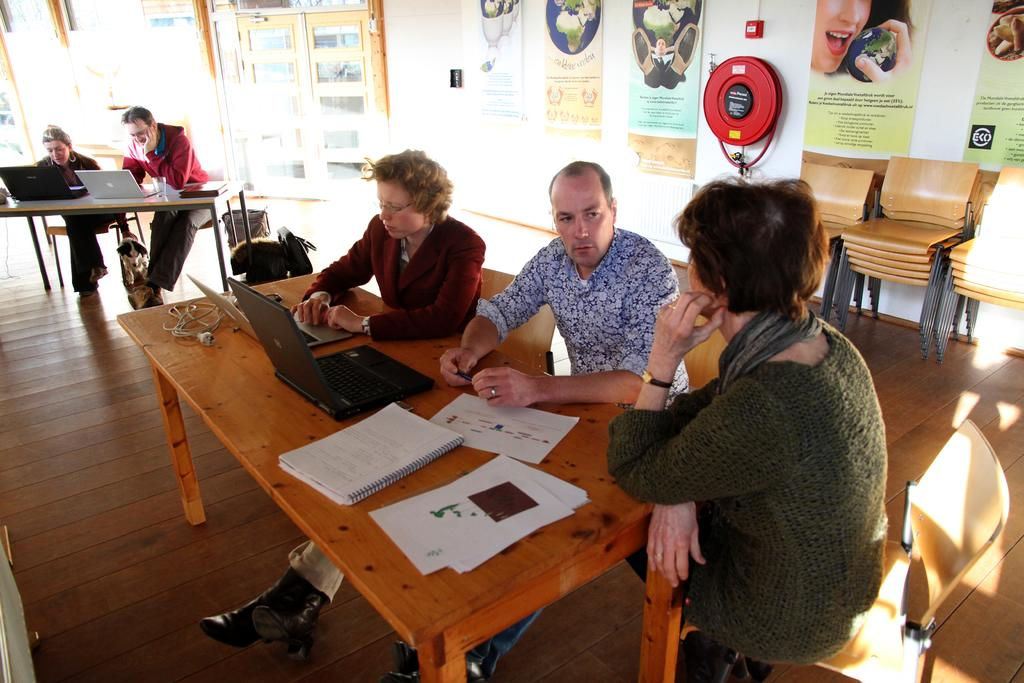How many people are in the image? There is a group of people in the image. What are the people doing in the image? The people are sitting on chairs. What is on the table in the image? There is a laptop, a file, and a book on the table. What can be seen in the background of the image? There are posters and a wall visible in the background. Are there any balloons present at the party in the image? There is no party or balloons present in the image. What is the relation between the people in the image? The provided facts do not give any information about the relationship between the people in the image. 